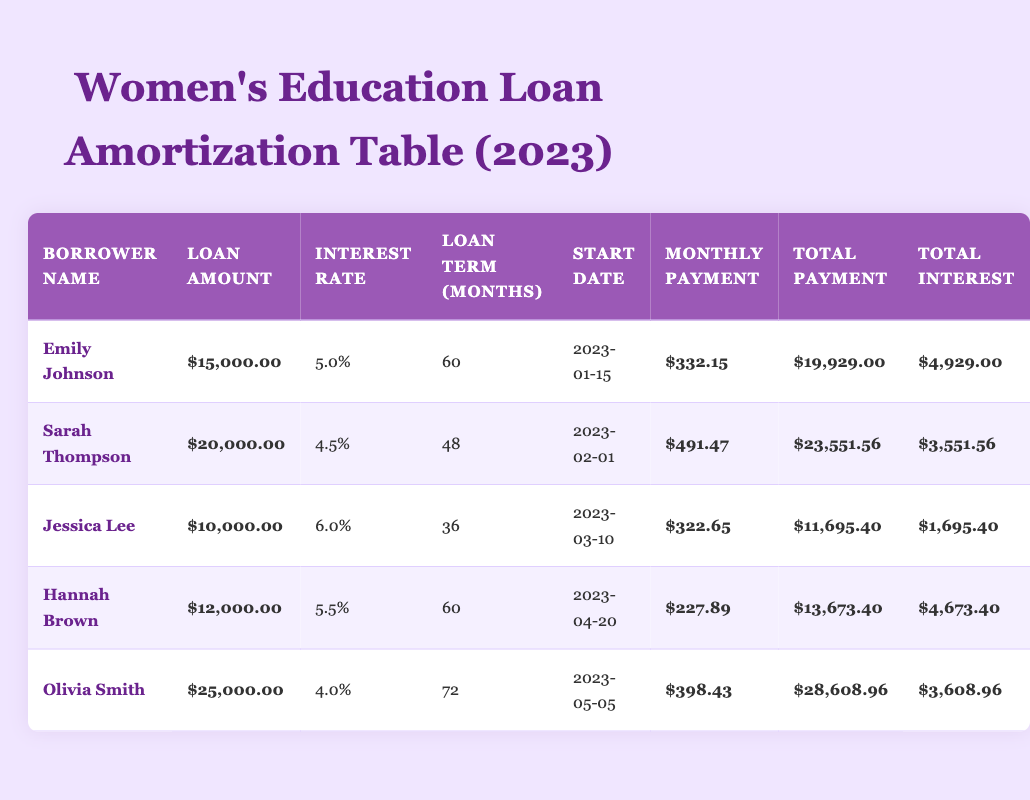What is the total amount borrowed by all the women in the table? To find the total amount borrowed, sum the loan amounts from each row. The loan amounts are: 15000, 20000, 10000, 12000, and 25000, which sum to 82000 (15000 + 20000 + 10000 + 12000 + 25000 = 82000).
Answer: 82000 Which borrower has the lowest total interest paid? To determine the borrower with the lowest total interest, compare the total interest values: 4929, 3551.56, 1695.40, 4673.40, and 3608.96. The lowest is 1695.40, which belongs to Jessica Lee.
Answer: Jessica Lee What is the average monthly payment for the loans listed? To find the average monthly payment, first sum the monthly payments: 332.15 + 491.47 + 322.65 + 227.89 + 398.43 = 1772.59. Then, divide by the number of borrowers (5): 1772.59 / 5 = 354.52.
Answer: 354.52 Is the total payment for Sarah Thompson greater than that for Olivia Smith? Compare Sarah Thompson's total payment (23551.56) with Olivia Smith's (28608.96). Since 23551.56 is less than 28608.96, the statement is false.
Answer: No How much total interest do the borrowers pay altogether? To find the total interest, sum the total interest values: 4929.00 + 3551.56 + 1695.40 + 4673.40 + 3608.96 = 18458.32.
Answer: 18458.32 Which borrower has the highest interest rate? Review the interest rates: 5.0, 4.5, 6.0, 5.5, and 4.0. The highest is 6.0, belonging to Jessica Lee.
Answer: Jessica Lee If Hannah Brown pays her loan off in 48 months instead of 60, how much total interest would she end up paying if her monthly payment remained the same? First, calculate the total payment over 48 months: 227.89 * 48 = 10999.52. The total interest would then be Total Payment - Loan Amount: 10999.52 - 12000 = -1000. This indicates she would not pay off the loan in this scenario.
Answer: Not applicable (debt not paid off) What is the total payment of all loans together? To find the total payment, sum the total payment values: 19929.00 + 23551.56 + 11695.40 + 13673.40 + 28608.96 = 107058.32.
Answer: 107058.32 Who has a higher total amount paid: Emily Johnson or Sarah Thompson? Compare their total payment amounts: Emily Johnson's is 19929.00, and Sarah Thompson's is 23551.56. Since 23551.56 is greater, Sarah Thompson has a higher total amount paid.
Answer: Sarah Thompson 